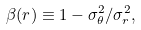Convert formula to latex. <formula><loc_0><loc_0><loc_500><loc_500>\beta ( r ) \equiv 1 - \sigma ^ { 2 } _ { \theta } / \sigma ^ { 2 } _ { r } ,</formula> 